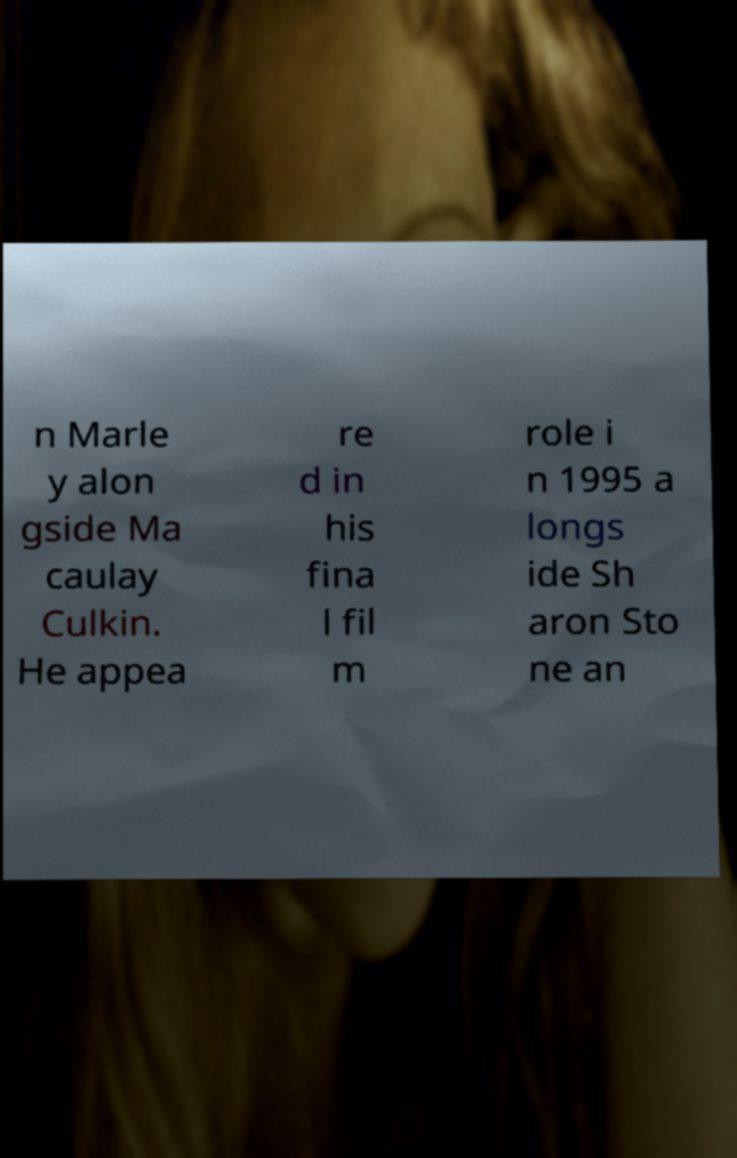I need the written content from this picture converted into text. Can you do that? n Marle y alon gside Ma caulay Culkin. He appea re d in his fina l fil m role i n 1995 a longs ide Sh aron Sto ne an 